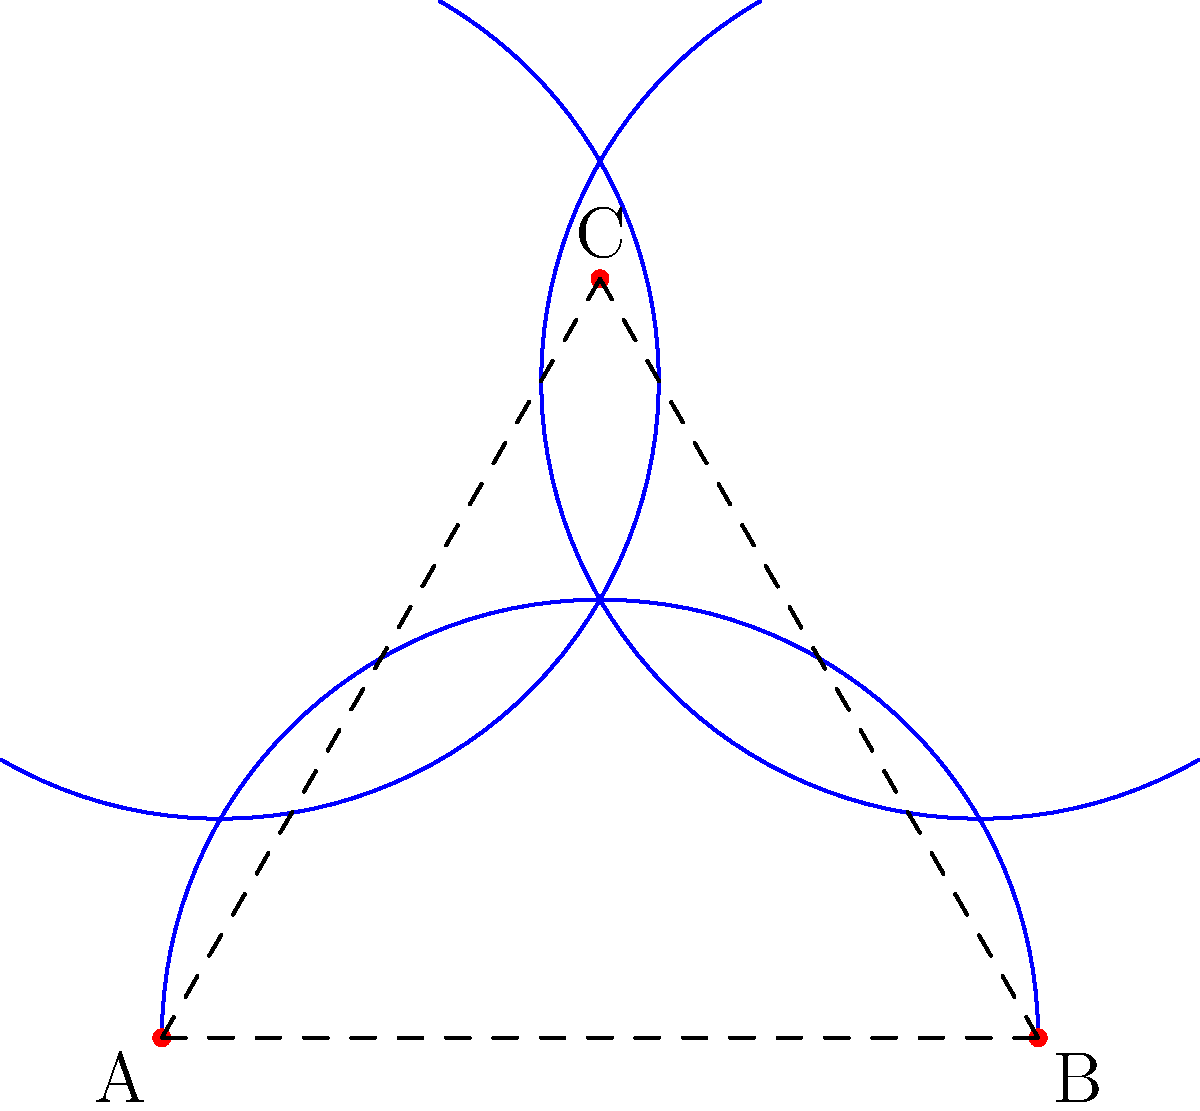Imagine you're sketching a landscape on a saddle-shaped surface, and you draw a triangle ABC as shown in the figure. Unlike on a flat canvas, the sum of the interior angles of this triangle is less than 180°. If angle A measures 50°, angle B measures 60°, and angle C measures 55°, what is the defect of the triangle (the difference between 180° and the sum of its interior angles)? To solve this problem, we need to follow these steps:

1. Recall that in Euclidean geometry, the sum of interior angles of a triangle is always 180°. However, on a saddle-shaped surface (which has negative curvature), the sum is less than 180°.

2. Calculate the sum of the given interior angles:
   $$ \text{Sum} = \angle A + \angle B + \angle C $$
   $$ \text{Sum} = 50° + 60° + 55° = 165° $$

3. The defect of a triangle is defined as the difference between 180° and the sum of its interior angles. Let's call this defect $\delta$:
   $$ \delta = 180° - \text{Sum of interior angles} $$

4. Substitute the sum we calculated:
   $$ \delta = 180° - 165° = 15° $$

5. This defect is directly related to the Gaussian curvature of the surface. A positive defect would indicate a surface with positive curvature (like a sphere), while a negative defect (which is impossible) would indicate an imaginary surface.

6. In this case, the positive defect confirms that we're dealing with a saddle-shaped surface, which has negative Gaussian curvature.
Answer: 15° 